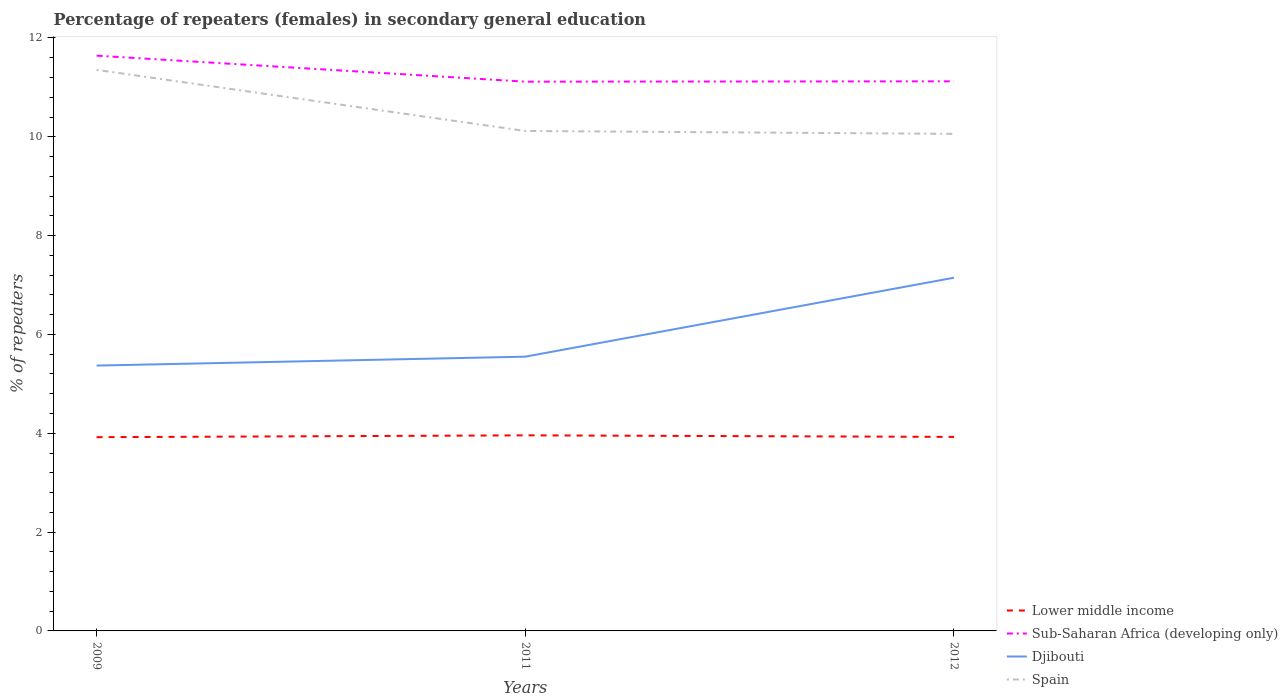Is the number of lines equal to the number of legend labels?
Your answer should be compact. Yes. Across all years, what is the maximum percentage of female repeaters in Spain?
Provide a succinct answer. 10.06. What is the total percentage of female repeaters in Spain in the graph?
Offer a very short reply. 1.3. What is the difference between the highest and the second highest percentage of female repeaters in Lower middle income?
Make the answer very short. 0.04. What is the difference between the highest and the lowest percentage of female repeaters in Lower middle income?
Your response must be concise. 1. Is the percentage of female repeaters in Lower middle income strictly greater than the percentage of female repeaters in Djibouti over the years?
Offer a very short reply. Yes. How many lines are there?
Provide a succinct answer. 4. How many years are there in the graph?
Offer a very short reply. 3. Are the values on the major ticks of Y-axis written in scientific E-notation?
Offer a terse response. No. Does the graph contain any zero values?
Offer a very short reply. No. Does the graph contain grids?
Offer a terse response. No. Where does the legend appear in the graph?
Your answer should be compact. Bottom right. What is the title of the graph?
Give a very brief answer. Percentage of repeaters (females) in secondary general education. What is the label or title of the X-axis?
Provide a short and direct response. Years. What is the label or title of the Y-axis?
Your answer should be very brief. % of repeaters. What is the % of repeaters of Lower middle income in 2009?
Your response must be concise. 3.92. What is the % of repeaters in Sub-Saharan Africa (developing only) in 2009?
Offer a terse response. 11.64. What is the % of repeaters in Djibouti in 2009?
Your response must be concise. 5.37. What is the % of repeaters of Spain in 2009?
Ensure brevity in your answer.  11.36. What is the % of repeaters in Lower middle income in 2011?
Give a very brief answer. 3.96. What is the % of repeaters of Sub-Saharan Africa (developing only) in 2011?
Your answer should be compact. 11.12. What is the % of repeaters of Djibouti in 2011?
Your response must be concise. 5.55. What is the % of repeaters of Spain in 2011?
Give a very brief answer. 10.12. What is the % of repeaters of Lower middle income in 2012?
Offer a very short reply. 3.93. What is the % of repeaters of Sub-Saharan Africa (developing only) in 2012?
Provide a short and direct response. 11.12. What is the % of repeaters of Djibouti in 2012?
Your answer should be very brief. 7.15. What is the % of repeaters in Spain in 2012?
Make the answer very short. 10.06. Across all years, what is the maximum % of repeaters of Lower middle income?
Your answer should be compact. 3.96. Across all years, what is the maximum % of repeaters of Sub-Saharan Africa (developing only)?
Offer a terse response. 11.64. Across all years, what is the maximum % of repeaters in Djibouti?
Ensure brevity in your answer.  7.15. Across all years, what is the maximum % of repeaters of Spain?
Provide a succinct answer. 11.36. Across all years, what is the minimum % of repeaters in Lower middle income?
Your answer should be very brief. 3.92. Across all years, what is the minimum % of repeaters in Sub-Saharan Africa (developing only)?
Give a very brief answer. 11.12. Across all years, what is the minimum % of repeaters of Djibouti?
Provide a succinct answer. 5.37. Across all years, what is the minimum % of repeaters of Spain?
Your response must be concise. 10.06. What is the total % of repeaters of Lower middle income in the graph?
Offer a terse response. 11.81. What is the total % of repeaters in Sub-Saharan Africa (developing only) in the graph?
Provide a short and direct response. 33.88. What is the total % of repeaters in Djibouti in the graph?
Your answer should be compact. 18.07. What is the total % of repeaters in Spain in the graph?
Ensure brevity in your answer.  31.53. What is the difference between the % of repeaters in Lower middle income in 2009 and that in 2011?
Provide a succinct answer. -0.04. What is the difference between the % of repeaters of Sub-Saharan Africa (developing only) in 2009 and that in 2011?
Provide a short and direct response. 0.53. What is the difference between the % of repeaters in Djibouti in 2009 and that in 2011?
Provide a short and direct response. -0.18. What is the difference between the % of repeaters in Spain in 2009 and that in 2011?
Your answer should be very brief. 1.24. What is the difference between the % of repeaters of Lower middle income in 2009 and that in 2012?
Ensure brevity in your answer.  -0.01. What is the difference between the % of repeaters in Sub-Saharan Africa (developing only) in 2009 and that in 2012?
Your answer should be very brief. 0.52. What is the difference between the % of repeaters of Djibouti in 2009 and that in 2012?
Keep it short and to the point. -1.78. What is the difference between the % of repeaters in Spain in 2009 and that in 2012?
Make the answer very short. 1.3. What is the difference between the % of repeaters in Lower middle income in 2011 and that in 2012?
Give a very brief answer. 0.03. What is the difference between the % of repeaters in Sub-Saharan Africa (developing only) in 2011 and that in 2012?
Your answer should be compact. -0.01. What is the difference between the % of repeaters of Djibouti in 2011 and that in 2012?
Your answer should be very brief. -1.6. What is the difference between the % of repeaters in Spain in 2011 and that in 2012?
Ensure brevity in your answer.  0.06. What is the difference between the % of repeaters of Lower middle income in 2009 and the % of repeaters of Sub-Saharan Africa (developing only) in 2011?
Offer a very short reply. -7.2. What is the difference between the % of repeaters of Lower middle income in 2009 and the % of repeaters of Djibouti in 2011?
Provide a succinct answer. -1.63. What is the difference between the % of repeaters in Lower middle income in 2009 and the % of repeaters in Spain in 2011?
Keep it short and to the point. -6.2. What is the difference between the % of repeaters in Sub-Saharan Africa (developing only) in 2009 and the % of repeaters in Djibouti in 2011?
Ensure brevity in your answer.  6.09. What is the difference between the % of repeaters in Sub-Saharan Africa (developing only) in 2009 and the % of repeaters in Spain in 2011?
Make the answer very short. 1.52. What is the difference between the % of repeaters in Djibouti in 2009 and the % of repeaters in Spain in 2011?
Offer a very short reply. -4.75. What is the difference between the % of repeaters of Lower middle income in 2009 and the % of repeaters of Sub-Saharan Africa (developing only) in 2012?
Keep it short and to the point. -7.2. What is the difference between the % of repeaters in Lower middle income in 2009 and the % of repeaters in Djibouti in 2012?
Offer a very short reply. -3.23. What is the difference between the % of repeaters in Lower middle income in 2009 and the % of repeaters in Spain in 2012?
Offer a very short reply. -6.14. What is the difference between the % of repeaters of Sub-Saharan Africa (developing only) in 2009 and the % of repeaters of Djibouti in 2012?
Your answer should be very brief. 4.49. What is the difference between the % of repeaters of Sub-Saharan Africa (developing only) in 2009 and the % of repeaters of Spain in 2012?
Give a very brief answer. 1.58. What is the difference between the % of repeaters in Djibouti in 2009 and the % of repeaters in Spain in 2012?
Keep it short and to the point. -4.69. What is the difference between the % of repeaters of Lower middle income in 2011 and the % of repeaters of Sub-Saharan Africa (developing only) in 2012?
Your answer should be compact. -7.16. What is the difference between the % of repeaters of Lower middle income in 2011 and the % of repeaters of Djibouti in 2012?
Your answer should be compact. -3.19. What is the difference between the % of repeaters in Lower middle income in 2011 and the % of repeaters in Spain in 2012?
Your answer should be very brief. -6.1. What is the difference between the % of repeaters in Sub-Saharan Africa (developing only) in 2011 and the % of repeaters in Djibouti in 2012?
Your answer should be very brief. 3.97. What is the difference between the % of repeaters of Sub-Saharan Africa (developing only) in 2011 and the % of repeaters of Spain in 2012?
Give a very brief answer. 1.06. What is the difference between the % of repeaters in Djibouti in 2011 and the % of repeaters in Spain in 2012?
Ensure brevity in your answer.  -4.51. What is the average % of repeaters of Lower middle income per year?
Provide a succinct answer. 3.94. What is the average % of repeaters in Sub-Saharan Africa (developing only) per year?
Offer a very short reply. 11.29. What is the average % of repeaters in Djibouti per year?
Ensure brevity in your answer.  6.02. What is the average % of repeaters in Spain per year?
Your answer should be very brief. 10.51. In the year 2009, what is the difference between the % of repeaters in Lower middle income and % of repeaters in Sub-Saharan Africa (developing only)?
Your answer should be very brief. -7.72. In the year 2009, what is the difference between the % of repeaters in Lower middle income and % of repeaters in Djibouti?
Provide a succinct answer. -1.45. In the year 2009, what is the difference between the % of repeaters of Lower middle income and % of repeaters of Spain?
Make the answer very short. -7.43. In the year 2009, what is the difference between the % of repeaters in Sub-Saharan Africa (developing only) and % of repeaters in Djibouti?
Make the answer very short. 6.27. In the year 2009, what is the difference between the % of repeaters in Sub-Saharan Africa (developing only) and % of repeaters in Spain?
Provide a succinct answer. 0.29. In the year 2009, what is the difference between the % of repeaters of Djibouti and % of repeaters of Spain?
Keep it short and to the point. -5.99. In the year 2011, what is the difference between the % of repeaters of Lower middle income and % of repeaters of Sub-Saharan Africa (developing only)?
Your response must be concise. -7.16. In the year 2011, what is the difference between the % of repeaters in Lower middle income and % of repeaters in Djibouti?
Keep it short and to the point. -1.59. In the year 2011, what is the difference between the % of repeaters of Lower middle income and % of repeaters of Spain?
Provide a short and direct response. -6.16. In the year 2011, what is the difference between the % of repeaters of Sub-Saharan Africa (developing only) and % of repeaters of Djibouti?
Provide a succinct answer. 5.57. In the year 2011, what is the difference between the % of repeaters of Djibouti and % of repeaters of Spain?
Give a very brief answer. -4.57. In the year 2012, what is the difference between the % of repeaters in Lower middle income and % of repeaters in Sub-Saharan Africa (developing only)?
Provide a succinct answer. -7.2. In the year 2012, what is the difference between the % of repeaters in Lower middle income and % of repeaters in Djibouti?
Keep it short and to the point. -3.22. In the year 2012, what is the difference between the % of repeaters in Lower middle income and % of repeaters in Spain?
Your response must be concise. -6.13. In the year 2012, what is the difference between the % of repeaters in Sub-Saharan Africa (developing only) and % of repeaters in Djibouti?
Your answer should be very brief. 3.97. In the year 2012, what is the difference between the % of repeaters of Sub-Saharan Africa (developing only) and % of repeaters of Spain?
Offer a terse response. 1.06. In the year 2012, what is the difference between the % of repeaters of Djibouti and % of repeaters of Spain?
Your answer should be compact. -2.91. What is the ratio of the % of repeaters in Lower middle income in 2009 to that in 2011?
Your answer should be compact. 0.99. What is the ratio of the % of repeaters of Sub-Saharan Africa (developing only) in 2009 to that in 2011?
Provide a short and direct response. 1.05. What is the ratio of the % of repeaters of Djibouti in 2009 to that in 2011?
Give a very brief answer. 0.97. What is the ratio of the % of repeaters in Spain in 2009 to that in 2011?
Make the answer very short. 1.12. What is the ratio of the % of repeaters of Sub-Saharan Africa (developing only) in 2009 to that in 2012?
Your response must be concise. 1.05. What is the ratio of the % of repeaters in Djibouti in 2009 to that in 2012?
Your response must be concise. 0.75. What is the ratio of the % of repeaters in Spain in 2009 to that in 2012?
Provide a short and direct response. 1.13. What is the ratio of the % of repeaters of Djibouti in 2011 to that in 2012?
Your response must be concise. 0.78. What is the difference between the highest and the second highest % of repeaters of Lower middle income?
Ensure brevity in your answer.  0.03. What is the difference between the highest and the second highest % of repeaters of Sub-Saharan Africa (developing only)?
Provide a succinct answer. 0.52. What is the difference between the highest and the second highest % of repeaters of Djibouti?
Ensure brevity in your answer.  1.6. What is the difference between the highest and the second highest % of repeaters in Spain?
Give a very brief answer. 1.24. What is the difference between the highest and the lowest % of repeaters in Lower middle income?
Offer a very short reply. 0.04. What is the difference between the highest and the lowest % of repeaters of Sub-Saharan Africa (developing only)?
Keep it short and to the point. 0.53. What is the difference between the highest and the lowest % of repeaters of Djibouti?
Your answer should be very brief. 1.78. What is the difference between the highest and the lowest % of repeaters in Spain?
Give a very brief answer. 1.3. 